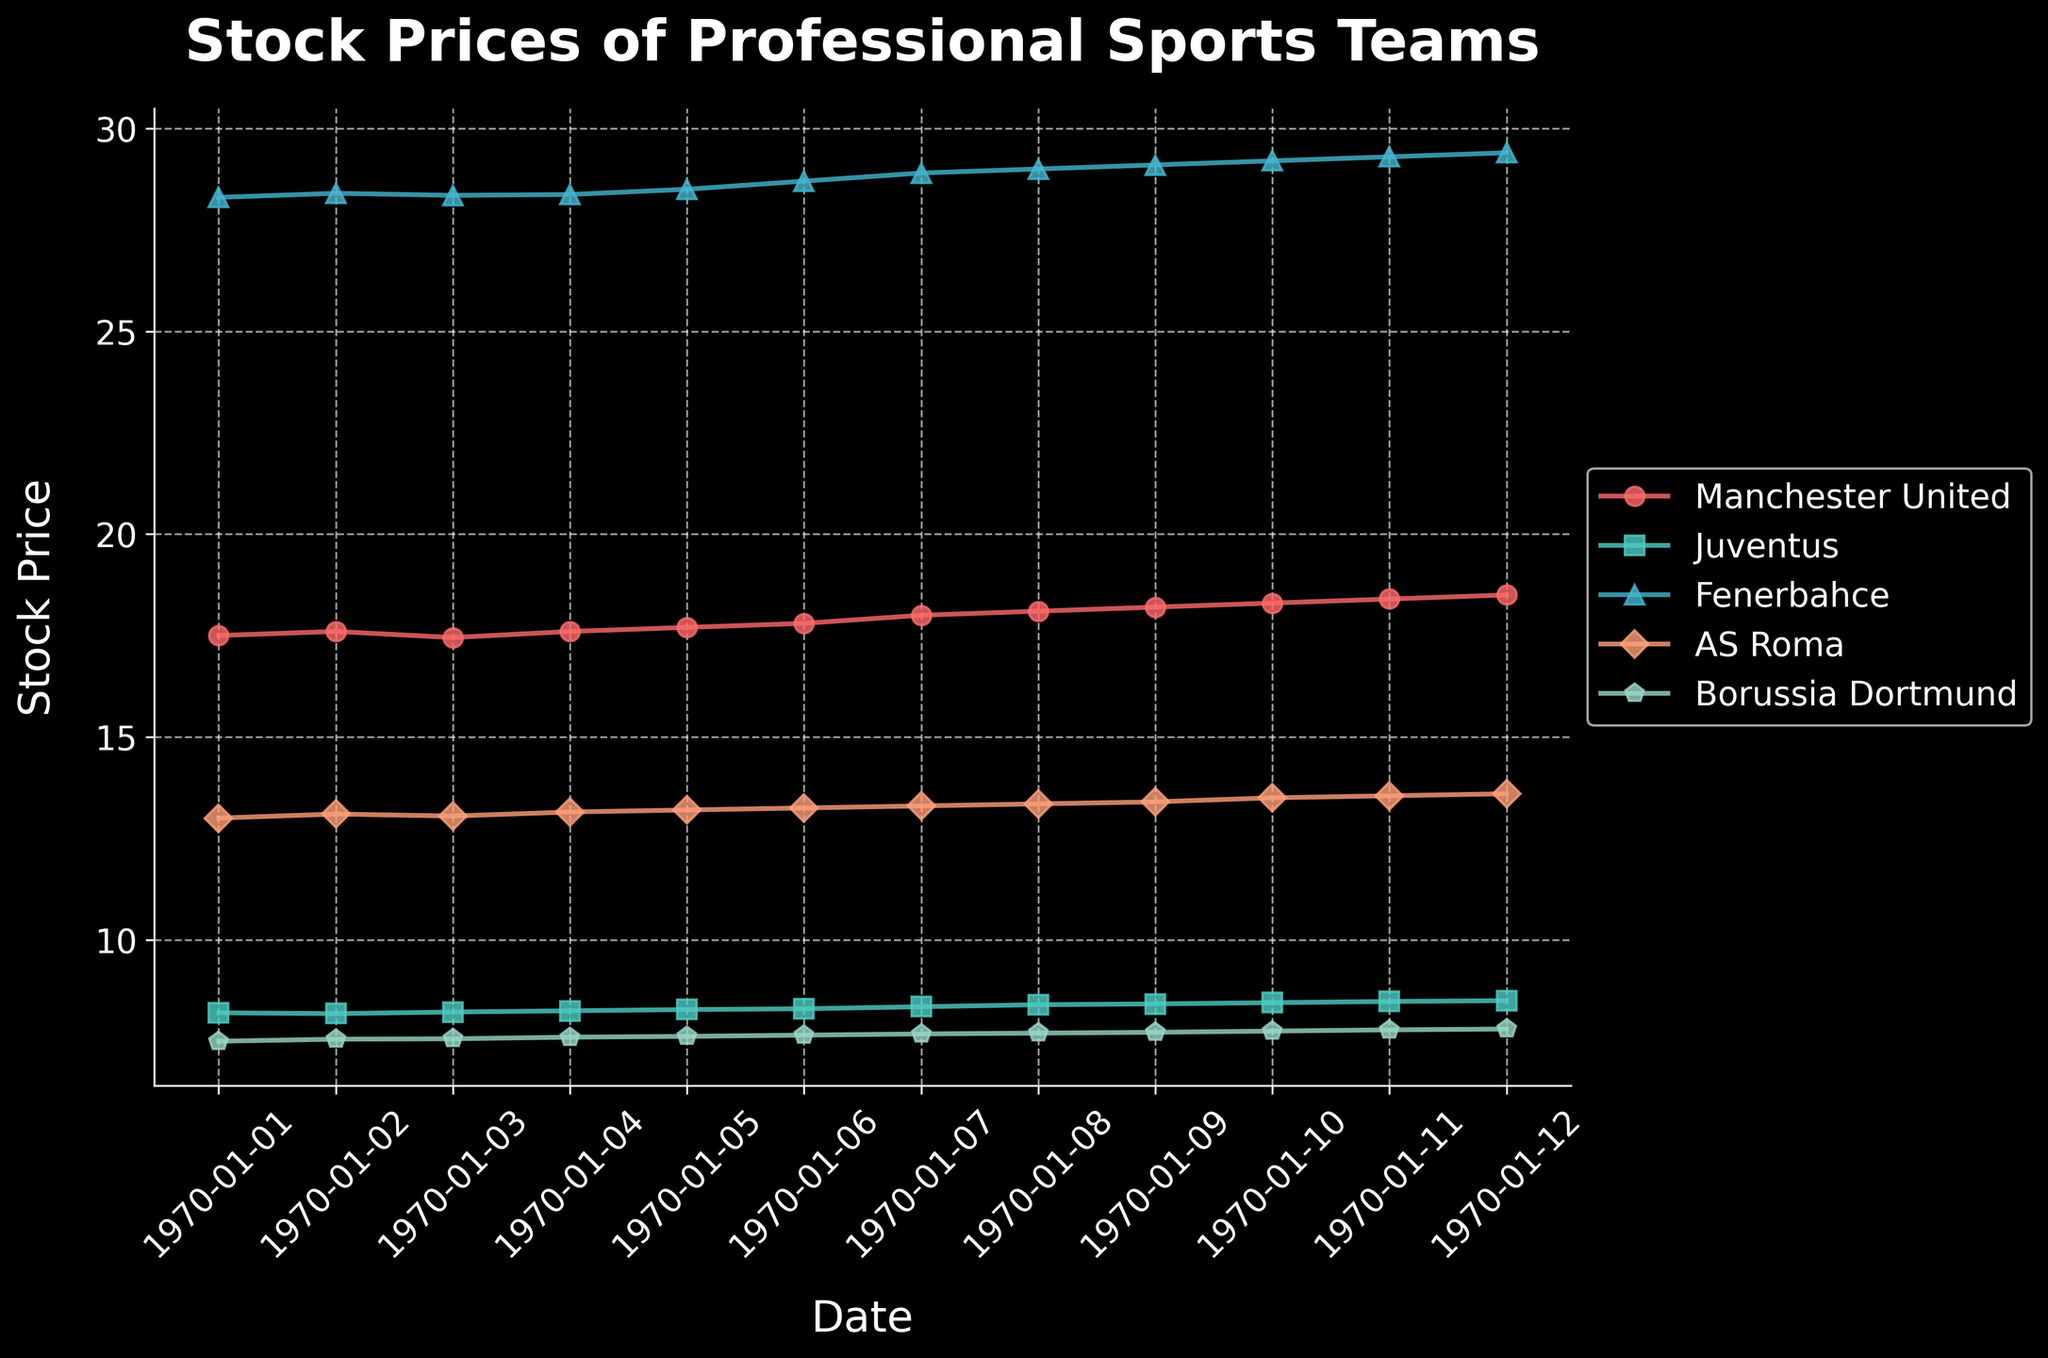When did the stock price of Manchester United first reach 18.00? Manchester United's stock price reaches 18.00 on January 7th, as indicated by tracking the date on the x-axis with the price on the y-axis.
Answer: January 7th What is the range of stock prices for Juventus during the given period? The lowest stock price for Juventus is 8.18 on January 2nd, and the highest is 8.50 on January 12th. The range is calculated as 8.50 - 8.18.
Answer: 0.32 Which team experienced the highest overall increase in stock price from January 1st to January 12th? To find the overall increase for each team, subtract the stock price on January 1st from that on January 12th and compare the results. Manchester United: 18.50 - 17.50 = 1.00, Juventus: 8.50 - 8.20 = 0.30, Fenerbahce: 29.40 - 28.30 = 1.10, AS Roma: 13.60 - 13.00 = 0.60, Borussia Dortmund: 7.80 - 7.50 = 0.30. Fenerbahce has the highest increase.
Answer: Fenerbahce On which date did AS Roma's stock price first surpass 13.50? AS Roma's stock price first surpasses 13.50 on January 10th as the stock price trends upwards, reaching 13.50 exactly on that date.
Answer: January 10th Which team had the least volatile stock prices in the given period? Volatility can be gauged by the range of stock prices for each team. Calculate the range for each: Manchester United: 18.50 - 17.50 = 1.00, Juventus: 8.50 - 8.18 = 0.32, Fenerbahce: 29.40 - 28.30 = 1.10, AS Roma: 13.60 - 13.00 = 0.60, Borussia Dortmund: 7.80 - 7.50 = 0.30. Borussia Dortmund has the smallest range (0.30).
Answer: Borussia Dortmund What is the average stock price of Borussia Dortmund during the given period? Sum Borussia Dortmund's stock prices from January 1st to January 12th and divide by the number of days. (7.50 + 7.55 + 7.56 + 7.60 + 7.62 + 7.65 + 7.68 + 7.70 + 7.72 + 7.75 + 7.78 + 7.80) / 12. The sum is 91.91, so the average is 91.91 / 12.
Answer: 7.66 